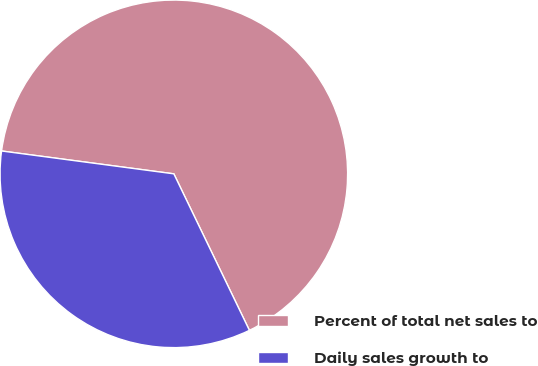Convert chart. <chart><loc_0><loc_0><loc_500><loc_500><pie_chart><fcel>Percent of total net sales to<fcel>Daily sales growth to<nl><fcel>65.74%<fcel>34.26%<nl></chart> 